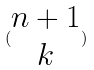<formula> <loc_0><loc_0><loc_500><loc_500>( \begin{matrix} n + 1 \\ k \end{matrix} )</formula> 